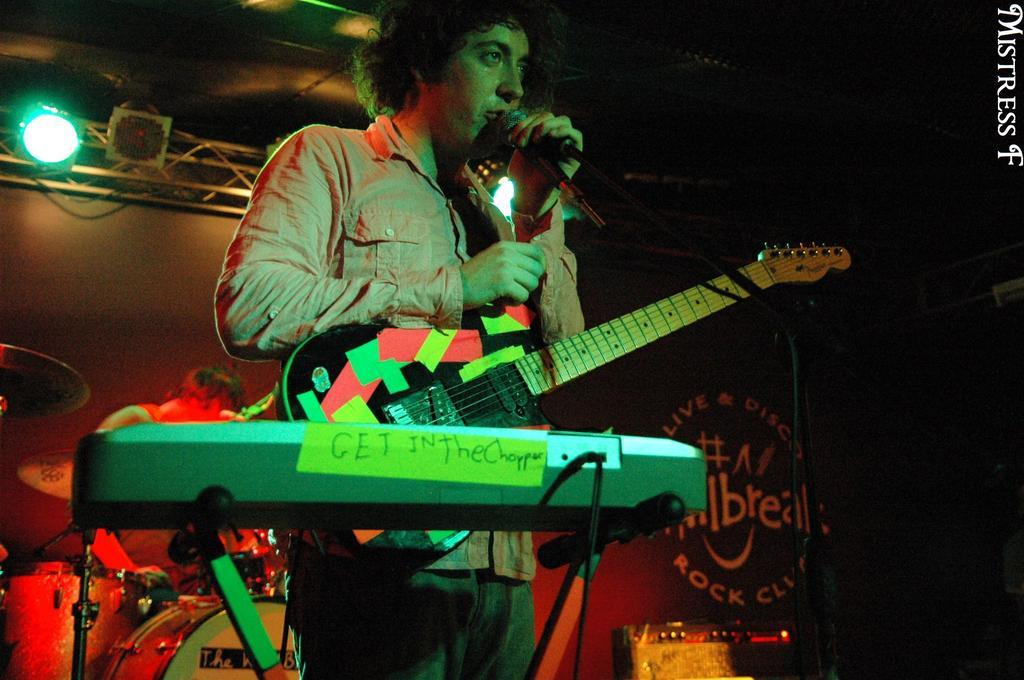What is the man in the image holding? The man is holding a microphone and a guitar. What instrument is in front of the man? There is a keyboard in front of the man. What other musical instruments can be seen in the image? There are drums in the background of the image. Are there any other people present in the image? Yes, there is another person in the background of the image. What can be seen in the background of the image besides the drums and the other person? There is light visible in the background of the image. What type of bottle is being used to measure the respect in the image? There is no bottle or measurement of respect present in the image. 